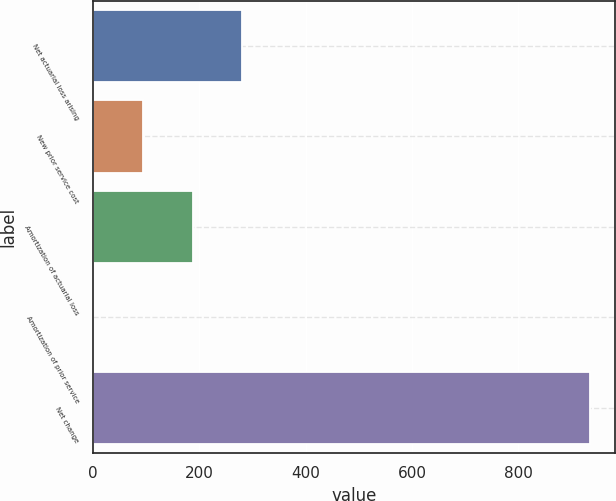<chart> <loc_0><loc_0><loc_500><loc_500><bar_chart><fcel>Net actuarial loss arising<fcel>New prior service cost<fcel>Amortization of actuarial loss<fcel>Amortization of prior service<fcel>Net change<nl><fcel>281.2<fcel>94.4<fcel>187.8<fcel>1<fcel>935<nl></chart> 